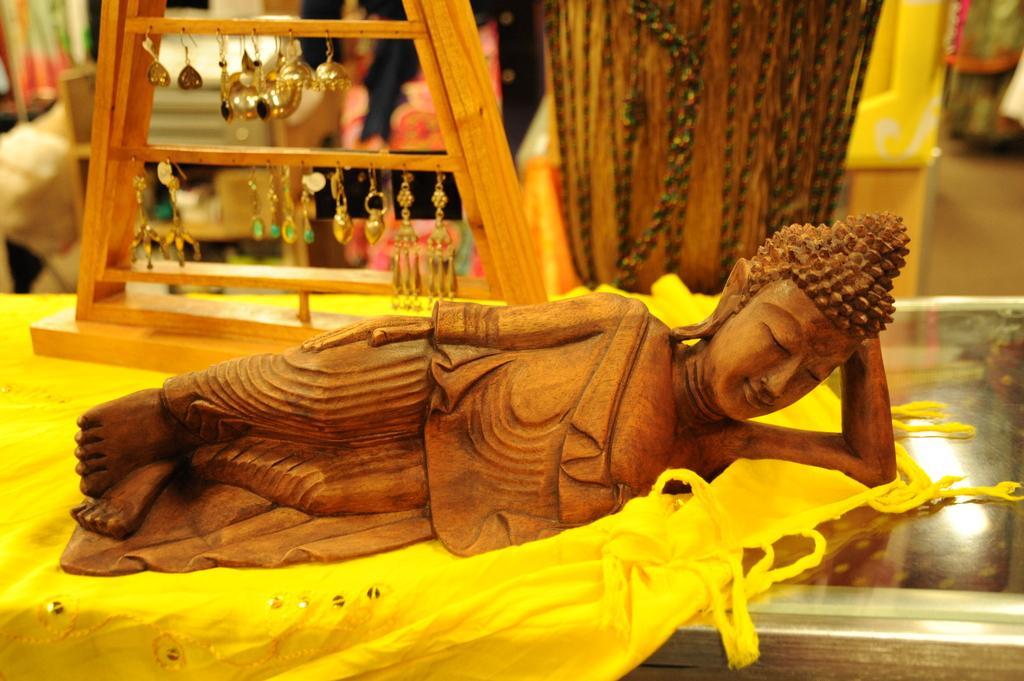Describe this image in one or two sentences. There is a small wooden sculpture of a sleeping man placed on a yellow cloth and behind that sculpture there is a collection of earrings hanged to the wooden rod and the background is blur. 